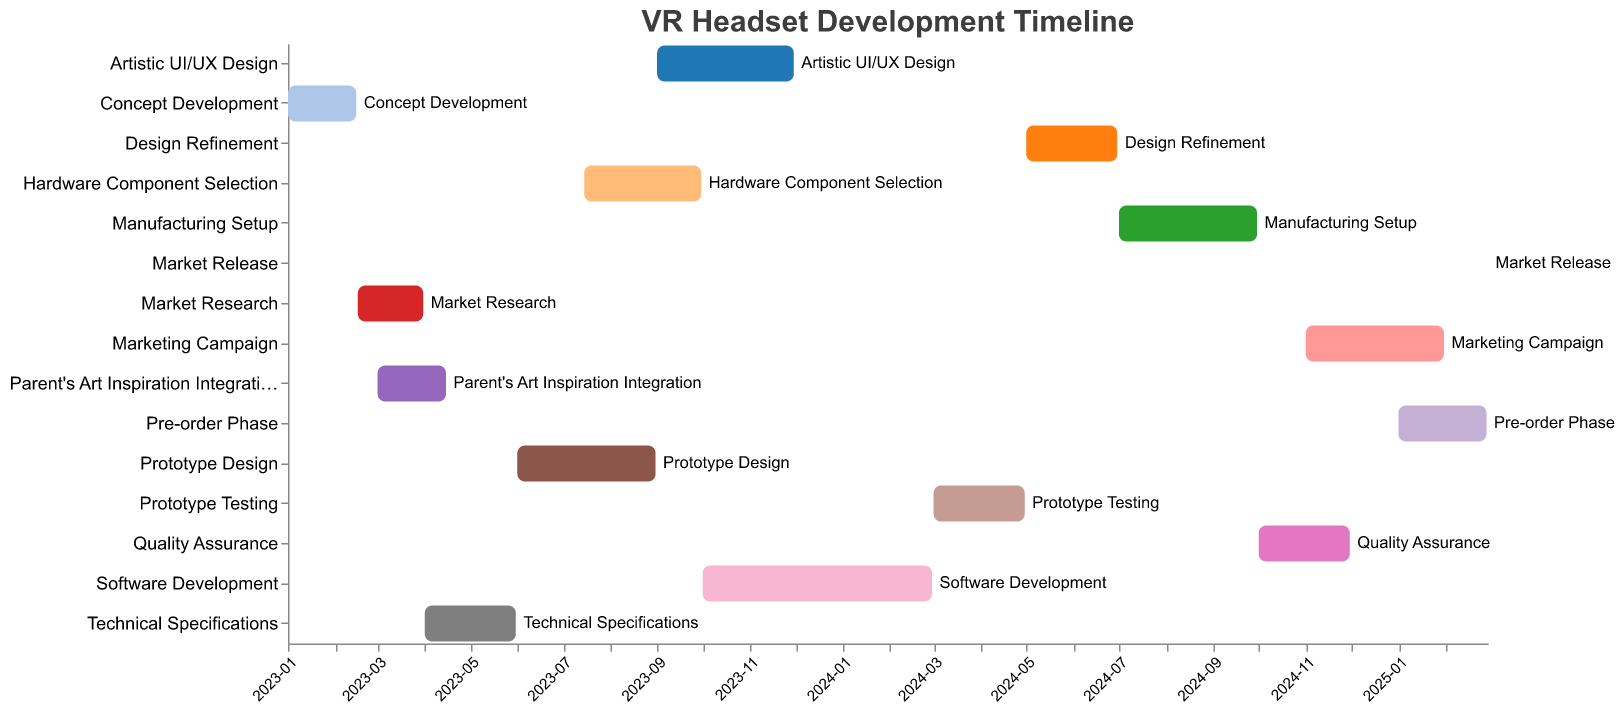What is the title of the Gantt Chart? The title is located at the top of the Gantt Chart.
Answer: VR Headset Development Timeline Which task has the longest duration? By comparing the start and end dates of all tasks and calculating their duration, the task with the greatest difference between these dates is the task with the longest duration.
Answer: Software Development When does the Marketing Campaign start and end? The start and end dates for the Marketing Campaign are displayed in the bar representing the task. The x-axis shows temporal information.
Answer: Starts on 2024-11-01 and ends on 2025-01-31 List all tasks overlapping with the Prototype Design phase. Identify tasks whose start or end dates fall between the start and end dates of the Prototype Design phase.
Answer: Hardware Component Selection and Artistic UI/UX Design How many tasks are scheduled to end in 2025? Check the end dates of all tasks to see how many extend to or end in the year 2025.
Answer: Three tasks Which task starts immediately after the Market Research phase ends? Market Research ends on 2023-03-31; the task starting immediately after this must begin on 2023-04-01, which is Technical Specifications.
Answer: Technical Specifications What is the duration of the Parent's Art Inspiration Integration task in days? Convert the start and end dates (2023-03-01 to 2023-04-15) to day counts and compute the difference.
Answer: 45 days Identify the task that begins after the longest gap from the end of its preceding task. To find the longest gap, calculate the time difference between the end of each task and the start of the next. Identify the maximum difference.
Answer: Marketing Campaign When does Quality Assurance take place? Find the start and end dates for the Quality Assurance task from the chart.
Answer: From 2024-10-01 to 2024-11-30 Compare the duration of the Design Refinement and Pre-order Phase tasks. Which one is shorter? Calculate the duration of each task by finding the difference between their respective start and end dates.
Answer: Pre-order Phase 